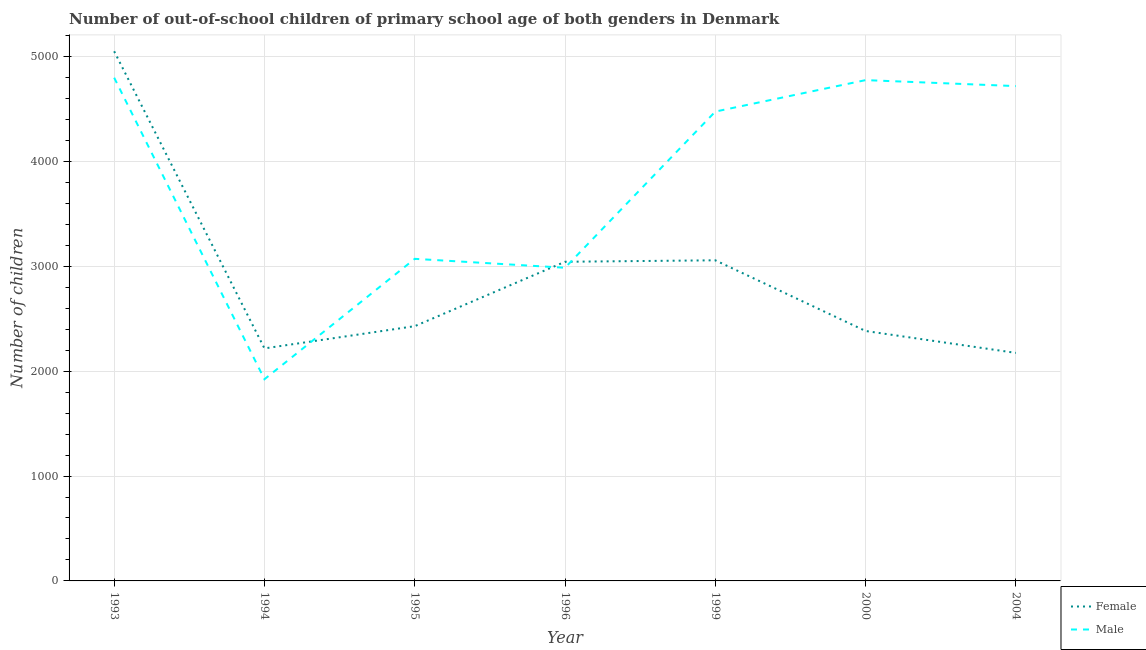How many different coloured lines are there?
Offer a terse response. 2. Is the number of lines equal to the number of legend labels?
Provide a succinct answer. Yes. What is the number of female out-of-school students in 1999?
Make the answer very short. 3057. Across all years, what is the maximum number of female out-of-school students?
Give a very brief answer. 5050. Across all years, what is the minimum number of male out-of-school students?
Ensure brevity in your answer.  1923. What is the total number of female out-of-school students in the graph?
Offer a terse response. 2.04e+04. What is the difference between the number of female out-of-school students in 1999 and that in 2004?
Offer a very short reply. 883. What is the difference between the number of male out-of-school students in 2004 and the number of female out-of-school students in 1993?
Your answer should be very brief. -332. What is the average number of male out-of-school students per year?
Make the answer very short. 3820.86. In the year 2000, what is the difference between the number of male out-of-school students and number of female out-of-school students?
Provide a succinct answer. 2392. In how many years, is the number of female out-of-school students greater than 2400?
Offer a terse response. 4. What is the ratio of the number of female out-of-school students in 1995 to that in 1999?
Ensure brevity in your answer.  0.79. Is the number of male out-of-school students in 1994 less than that in 1995?
Give a very brief answer. Yes. Is the difference between the number of female out-of-school students in 1995 and 2004 greater than the difference between the number of male out-of-school students in 1995 and 2004?
Offer a terse response. Yes. What is the difference between the highest and the second highest number of female out-of-school students?
Your response must be concise. 1993. What is the difference between the highest and the lowest number of male out-of-school students?
Make the answer very short. 2875. In how many years, is the number of male out-of-school students greater than the average number of male out-of-school students taken over all years?
Your answer should be very brief. 4. Is the number of male out-of-school students strictly greater than the number of female out-of-school students over the years?
Keep it short and to the point. No. What is the difference between two consecutive major ticks on the Y-axis?
Your answer should be very brief. 1000. Does the graph contain any zero values?
Ensure brevity in your answer.  No. Where does the legend appear in the graph?
Give a very brief answer. Bottom right. How many legend labels are there?
Offer a terse response. 2. What is the title of the graph?
Your answer should be very brief. Number of out-of-school children of primary school age of both genders in Denmark. Does "From Government" appear as one of the legend labels in the graph?
Your answer should be compact. No. What is the label or title of the Y-axis?
Make the answer very short. Number of children. What is the Number of children of Female in 1993?
Give a very brief answer. 5050. What is the Number of children in Male in 1993?
Give a very brief answer. 4798. What is the Number of children of Female in 1994?
Ensure brevity in your answer.  2217. What is the Number of children in Male in 1994?
Your answer should be very brief. 1923. What is the Number of children of Female in 1995?
Offer a terse response. 2429. What is the Number of children in Male in 1995?
Your response must be concise. 3071. What is the Number of children of Female in 1996?
Keep it short and to the point. 3043. What is the Number of children of Male in 1996?
Keep it short and to the point. 2986. What is the Number of children in Female in 1999?
Provide a succinct answer. 3057. What is the Number of children in Male in 1999?
Ensure brevity in your answer.  4475. What is the Number of children in Female in 2000?
Offer a terse response. 2383. What is the Number of children in Male in 2000?
Provide a short and direct response. 4775. What is the Number of children in Female in 2004?
Your response must be concise. 2174. What is the Number of children in Male in 2004?
Make the answer very short. 4718. Across all years, what is the maximum Number of children in Female?
Provide a short and direct response. 5050. Across all years, what is the maximum Number of children of Male?
Provide a short and direct response. 4798. Across all years, what is the minimum Number of children in Female?
Your answer should be compact. 2174. Across all years, what is the minimum Number of children in Male?
Offer a terse response. 1923. What is the total Number of children in Female in the graph?
Your answer should be very brief. 2.04e+04. What is the total Number of children of Male in the graph?
Give a very brief answer. 2.67e+04. What is the difference between the Number of children in Female in 1993 and that in 1994?
Your response must be concise. 2833. What is the difference between the Number of children of Male in 1993 and that in 1994?
Make the answer very short. 2875. What is the difference between the Number of children of Female in 1993 and that in 1995?
Keep it short and to the point. 2621. What is the difference between the Number of children in Male in 1993 and that in 1995?
Provide a succinct answer. 1727. What is the difference between the Number of children in Female in 1993 and that in 1996?
Offer a very short reply. 2007. What is the difference between the Number of children of Male in 1993 and that in 1996?
Provide a succinct answer. 1812. What is the difference between the Number of children in Female in 1993 and that in 1999?
Ensure brevity in your answer.  1993. What is the difference between the Number of children in Male in 1993 and that in 1999?
Make the answer very short. 323. What is the difference between the Number of children in Female in 1993 and that in 2000?
Keep it short and to the point. 2667. What is the difference between the Number of children in Female in 1993 and that in 2004?
Your response must be concise. 2876. What is the difference between the Number of children in Male in 1993 and that in 2004?
Provide a short and direct response. 80. What is the difference between the Number of children in Female in 1994 and that in 1995?
Make the answer very short. -212. What is the difference between the Number of children in Male in 1994 and that in 1995?
Provide a succinct answer. -1148. What is the difference between the Number of children of Female in 1994 and that in 1996?
Make the answer very short. -826. What is the difference between the Number of children of Male in 1994 and that in 1996?
Give a very brief answer. -1063. What is the difference between the Number of children in Female in 1994 and that in 1999?
Offer a terse response. -840. What is the difference between the Number of children of Male in 1994 and that in 1999?
Keep it short and to the point. -2552. What is the difference between the Number of children of Female in 1994 and that in 2000?
Give a very brief answer. -166. What is the difference between the Number of children in Male in 1994 and that in 2000?
Your answer should be very brief. -2852. What is the difference between the Number of children in Female in 1994 and that in 2004?
Your answer should be compact. 43. What is the difference between the Number of children of Male in 1994 and that in 2004?
Ensure brevity in your answer.  -2795. What is the difference between the Number of children of Female in 1995 and that in 1996?
Make the answer very short. -614. What is the difference between the Number of children in Male in 1995 and that in 1996?
Your response must be concise. 85. What is the difference between the Number of children in Female in 1995 and that in 1999?
Provide a short and direct response. -628. What is the difference between the Number of children in Male in 1995 and that in 1999?
Offer a terse response. -1404. What is the difference between the Number of children of Female in 1995 and that in 2000?
Keep it short and to the point. 46. What is the difference between the Number of children of Male in 1995 and that in 2000?
Offer a very short reply. -1704. What is the difference between the Number of children of Female in 1995 and that in 2004?
Keep it short and to the point. 255. What is the difference between the Number of children of Male in 1995 and that in 2004?
Your answer should be very brief. -1647. What is the difference between the Number of children of Male in 1996 and that in 1999?
Keep it short and to the point. -1489. What is the difference between the Number of children in Female in 1996 and that in 2000?
Make the answer very short. 660. What is the difference between the Number of children in Male in 1996 and that in 2000?
Provide a succinct answer. -1789. What is the difference between the Number of children in Female in 1996 and that in 2004?
Your response must be concise. 869. What is the difference between the Number of children of Male in 1996 and that in 2004?
Your answer should be very brief. -1732. What is the difference between the Number of children in Female in 1999 and that in 2000?
Your answer should be compact. 674. What is the difference between the Number of children in Male in 1999 and that in 2000?
Make the answer very short. -300. What is the difference between the Number of children of Female in 1999 and that in 2004?
Your answer should be compact. 883. What is the difference between the Number of children in Male in 1999 and that in 2004?
Provide a short and direct response. -243. What is the difference between the Number of children in Female in 2000 and that in 2004?
Your answer should be very brief. 209. What is the difference between the Number of children in Female in 1993 and the Number of children in Male in 1994?
Make the answer very short. 3127. What is the difference between the Number of children of Female in 1993 and the Number of children of Male in 1995?
Make the answer very short. 1979. What is the difference between the Number of children in Female in 1993 and the Number of children in Male in 1996?
Provide a short and direct response. 2064. What is the difference between the Number of children of Female in 1993 and the Number of children of Male in 1999?
Make the answer very short. 575. What is the difference between the Number of children of Female in 1993 and the Number of children of Male in 2000?
Give a very brief answer. 275. What is the difference between the Number of children of Female in 1993 and the Number of children of Male in 2004?
Your answer should be compact. 332. What is the difference between the Number of children in Female in 1994 and the Number of children in Male in 1995?
Your answer should be compact. -854. What is the difference between the Number of children in Female in 1994 and the Number of children in Male in 1996?
Offer a very short reply. -769. What is the difference between the Number of children in Female in 1994 and the Number of children in Male in 1999?
Your answer should be compact. -2258. What is the difference between the Number of children of Female in 1994 and the Number of children of Male in 2000?
Keep it short and to the point. -2558. What is the difference between the Number of children of Female in 1994 and the Number of children of Male in 2004?
Your response must be concise. -2501. What is the difference between the Number of children in Female in 1995 and the Number of children in Male in 1996?
Offer a terse response. -557. What is the difference between the Number of children in Female in 1995 and the Number of children in Male in 1999?
Your answer should be compact. -2046. What is the difference between the Number of children in Female in 1995 and the Number of children in Male in 2000?
Provide a short and direct response. -2346. What is the difference between the Number of children in Female in 1995 and the Number of children in Male in 2004?
Provide a succinct answer. -2289. What is the difference between the Number of children in Female in 1996 and the Number of children in Male in 1999?
Your answer should be very brief. -1432. What is the difference between the Number of children in Female in 1996 and the Number of children in Male in 2000?
Give a very brief answer. -1732. What is the difference between the Number of children of Female in 1996 and the Number of children of Male in 2004?
Offer a very short reply. -1675. What is the difference between the Number of children of Female in 1999 and the Number of children of Male in 2000?
Give a very brief answer. -1718. What is the difference between the Number of children of Female in 1999 and the Number of children of Male in 2004?
Make the answer very short. -1661. What is the difference between the Number of children of Female in 2000 and the Number of children of Male in 2004?
Make the answer very short. -2335. What is the average Number of children in Female per year?
Provide a succinct answer. 2907.57. What is the average Number of children of Male per year?
Provide a succinct answer. 3820.86. In the year 1993, what is the difference between the Number of children of Female and Number of children of Male?
Give a very brief answer. 252. In the year 1994, what is the difference between the Number of children in Female and Number of children in Male?
Your response must be concise. 294. In the year 1995, what is the difference between the Number of children of Female and Number of children of Male?
Provide a short and direct response. -642. In the year 1996, what is the difference between the Number of children in Female and Number of children in Male?
Make the answer very short. 57. In the year 1999, what is the difference between the Number of children of Female and Number of children of Male?
Your response must be concise. -1418. In the year 2000, what is the difference between the Number of children of Female and Number of children of Male?
Provide a short and direct response. -2392. In the year 2004, what is the difference between the Number of children in Female and Number of children in Male?
Offer a very short reply. -2544. What is the ratio of the Number of children in Female in 1993 to that in 1994?
Your answer should be very brief. 2.28. What is the ratio of the Number of children of Male in 1993 to that in 1994?
Your answer should be compact. 2.5. What is the ratio of the Number of children in Female in 1993 to that in 1995?
Your response must be concise. 2.08. What is the ratio of the Number of children of Male in 1993 to that in 1995?
Make the answer very short. 1.56. What is the ratio of the Number of children of Female in 1993 to that in 1996?
Provide a short and direct response. 1.66. What is the ratio of the Number of children of Male in 1993 to that in 1996?
Keep it short and to the point. 1.61. What is the ratio of the Number of children of Female in 1993 to that in 1999?
Offer a very short reply. 1.65. What is the ratio of the Number of children of Male in 1993 to that in 1999?
Offer a very short reply. 1.07. What is the ratio of the Number of children of Female in 1993 to that in 2000?
Give a very brief answer. 2.12. What is the ratio of the Number of children in Male in 1993 to that in 2000?
Give a very brief answer. 1. What is the ratio of the Number of children in Female in 1993 to that in 2004?
Provide a succinct answer. 2.32. What is the ratio of the Number of children in Male in 1993 to that in 2004?
Your response must be concise. 1.02. What is the ratio of the Number of children in Female in 1994 to that in 1995?
Ensure brevity in your answer.  0.91. What is the ratio of the Number of children in Male in 1994 to that in 1995?
Make the answer very short. 0.63. What is the ratio of the Number of children in Female in 1994 to that in 1996?
Ensure brevity in your answer.  0.73. What is the ratio of the Number of children of Male in 1994 to that in 1996?
Your response must be concise. 0.64. What is the ratio of the Number of children in Female in 1994 to that in 1999?
Your response must be concise. 0.73. What is the ratio of the Number of children of Male in 1994 to that in 1999?
Your answer should be very brief. 0.43. What is the ratio of the Number of children of Female in 1994 to that in 2000?
Your response must be concise. 0.93. What is the ratio of the Number of children of Male in 1994 to that in 2000?
Make the answer very short. 0.4. What is the ratio of the Number of children of Female in 1994 to that in 2004?
Offer a terse response. 1.02. What is the ratio of the Number of children in Male in 1994 to that in 2004?
Offer a terse response. 0.41. What is the ratio of the Number of children of Female in 1995 to that in 1996?
Offer a very short reply. 0.8. What is the ratio of the Number of children of Male in 1995 to that in 1996?
Give a very brief answer. 1.03. What is the ratio of the Number of children of Female in 1995 to that in 1999?
Give a very brief answer. 0.79. What is the ratio of the Number of children of Male in 1995 to that in 1999?
Give a very brief answer. 0.69. What is the ratio of the Number of children of Female in 1995 to that in 2000?
Provide a short and direct response. 1.02. What is the ratio of the Number of children in Male in 1995 to that in 2000?
Make the answer very short. 0.64. What is the ratio of the Number of children of Female in 1995 to that in 2004?
Offer a very short reply. 1.12. What is the ratio of the Number of children in Male in 1995 to that in 2004?
Provide a succinct answer. 0.65. What is the ratio of the Number of children of Female in 1996 to that in 1999?
Provide a succinct answer. 1. What is the ratio of the Number of children of Male in 1996 to that in 1999?
Provide a succinct answer. 0.67. What is the ratio of the Number of children in Female in 1996 to that in 2000?
Give a very brief answer. 1.28. What is the ratio of the Number of children in Male in 1996 to that in 2000?
Your response must be concise. 0.63. What is the ratio of the Number of children of Female in 1996 to that in 2004?
Give a very brief answer. 1.4. What is the ratio of the Number of children of Male in 1996 to that in 2004?
Your answer should be compact. 0.63. What is the ratio of the Number of children of Female in 1999 to that in 2000?
Provide a short and direct response. 1.28. What is the ratio of the Number of children in Male in 1999 to that in 2000?
Make the answer very short. 0.94. What is the ratio of the Number of children in Female in 1999 to that in 2004?
Your response must be concise. 1.41. What is the ratio of the Number of children of Male in 1999 to that in 2004?
Your answer should be compact. 0.95. What is the ratio of the Number of children of Female in 2000 to that in 2004?
Make the answer very short. 1.1. What is the ratio of the Number of children in Male in 2000 to that in 2004?
Your response must be concise. 1.01. What is the difference between the highest and the second highest Number of children in Female?
Offer a terse response. 1993. What is the difference between the highest and the lowest Number of children of Female?
Provide a short and direct response. 2876. What is the difference between the highest and the lowest Number of children in Male?
Your answer should be very brief. 2875. 